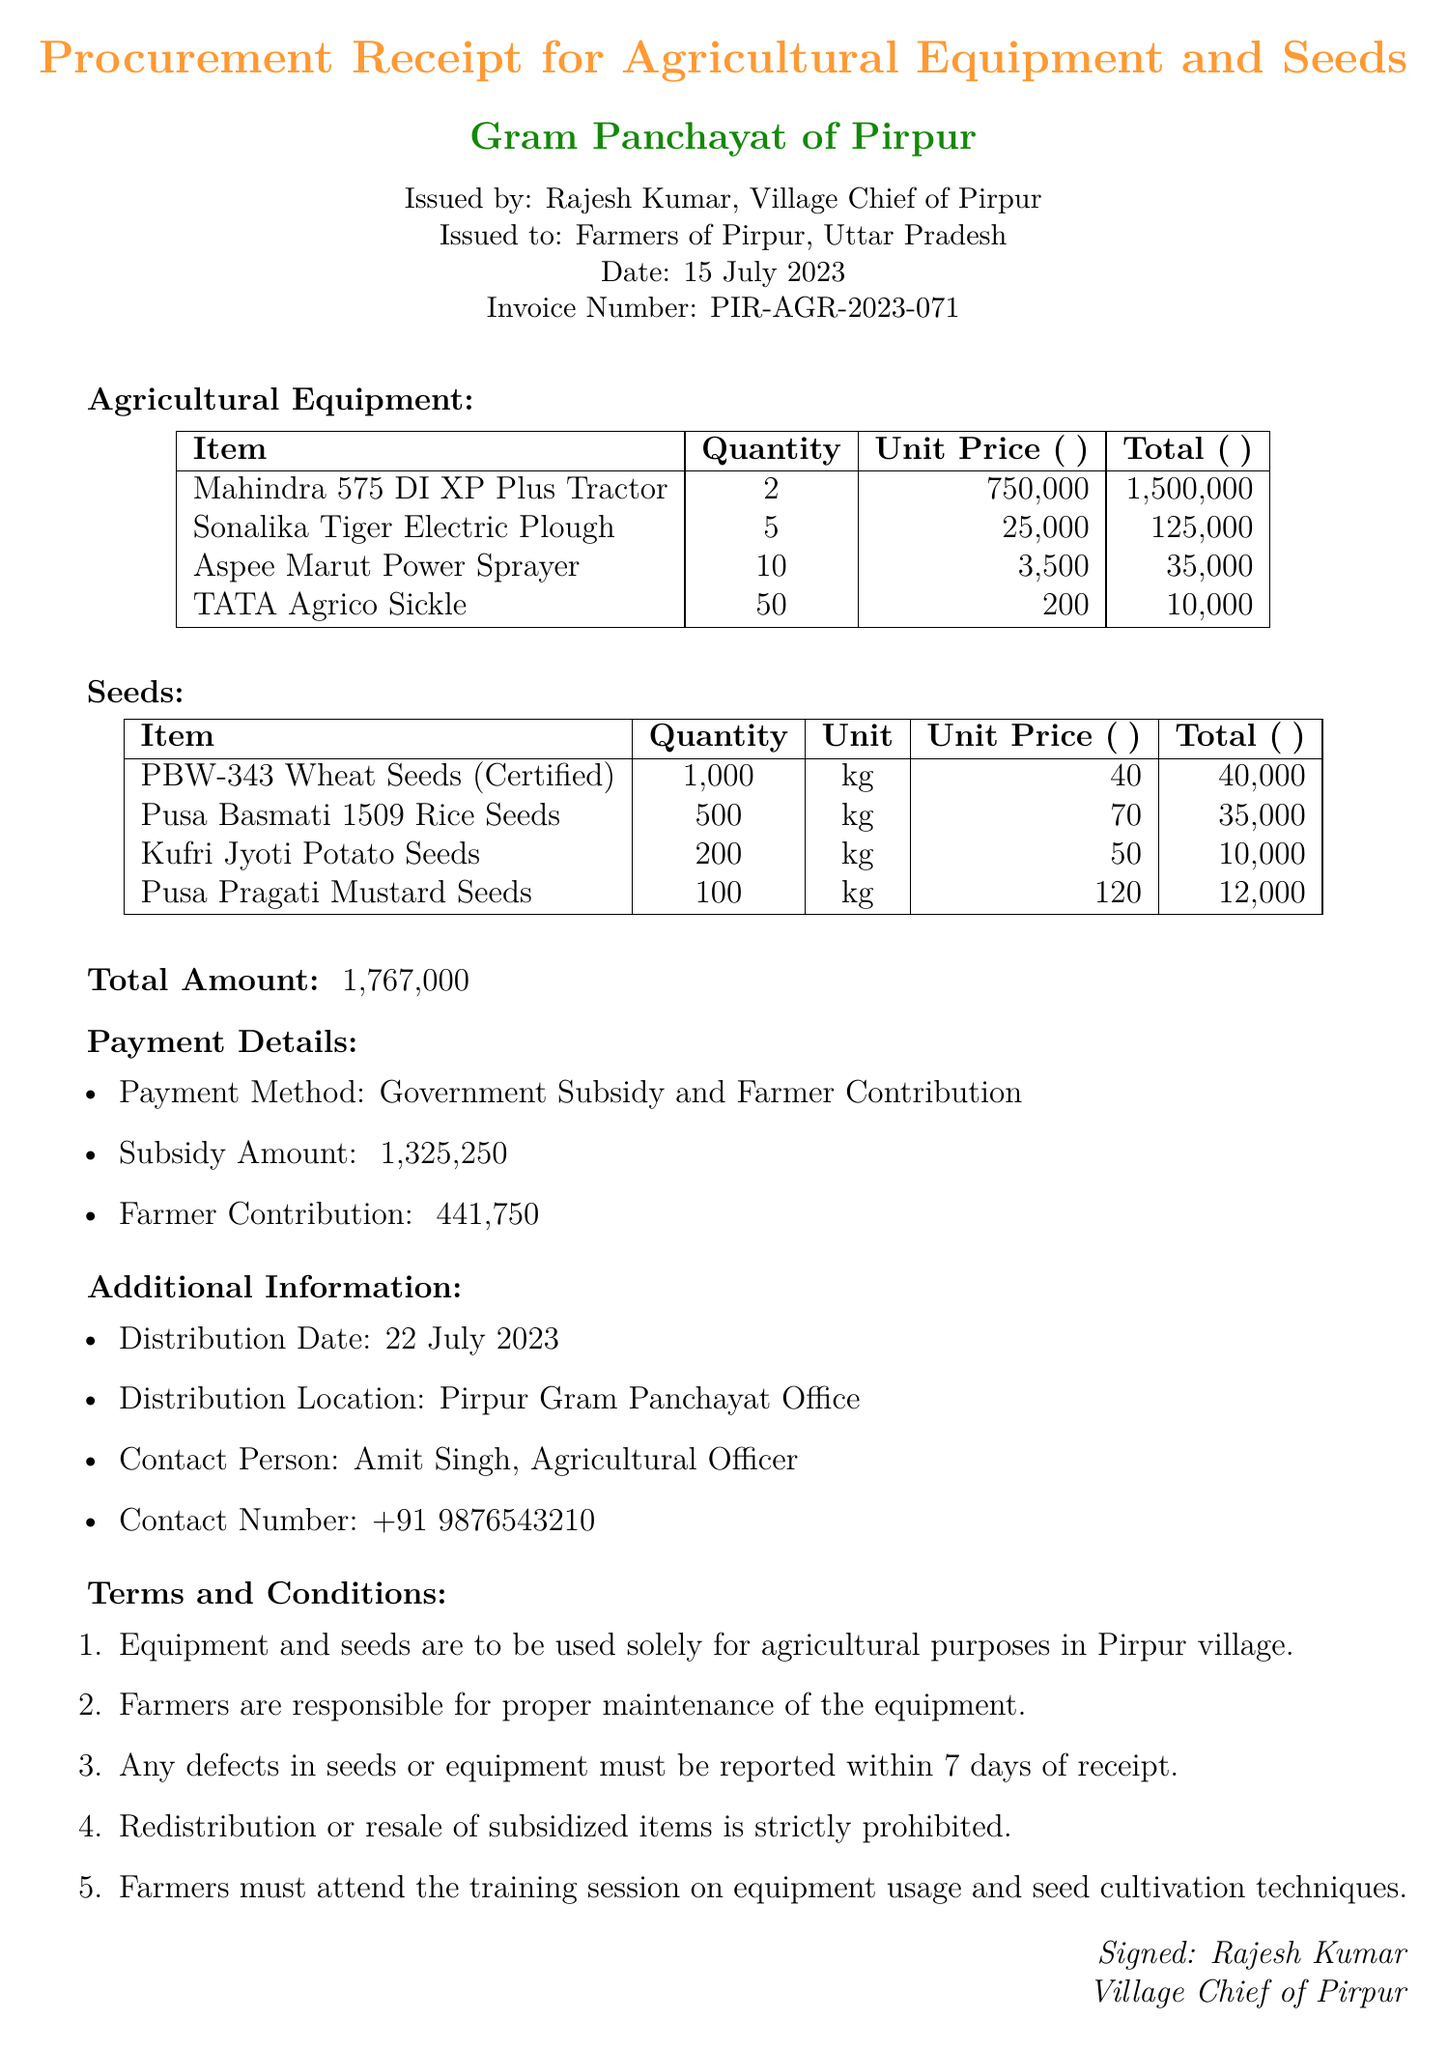What is the title of the document? The title is the main heading indicating the purpose of the document, which is "Procurement Receipt for Agricultural Equipment and Seeds."
Answer: Procurement Receipt for Agricultural Equipment and Seeds Who issued the invoice? The issuer is indicated in the document, which states that it was issued by "Rajesh Kumar, Village Chief of Pirpur."
Answer: Rajesh Kumar, Village Chief of Pirpur What is the total amount of the invoice? The total amount is provided at the end of the document, which summarizes the costs for equipment and seeds.
Answer: ₹1,767,000 What is the date of issuance? The date of issuance is specified in the header of the document as "15 July 2023."
Answer: 15 July 2023 How many Mahindra 575 DI XP Plus Tractors were procured? The quantity of Mahindra 575 DI XP Plus Tractors is detailed in the equipment section of the document.
Answer: 2 What is the distribution date for the items? The distribution date is mentioned in the additional information section of the document as "22 July 2023."
Answer: 22 July 2023 What percentage of the total amount is covered by the government subsidy? The document states the subsidy amount and the total amount, which can be calculated to find the percentage.
Answer: 75% What responsibilities do farmers have regarding the maintenance? The document includes a term stating that "Farmers are responsible for proper maintenance of the equipment."
Answer: Proper maintenance of the equipment What is the contact number for the Agricultural Officer? The contact number is provided in the additional information section for easier reach.
Answer: +91 9876543210 